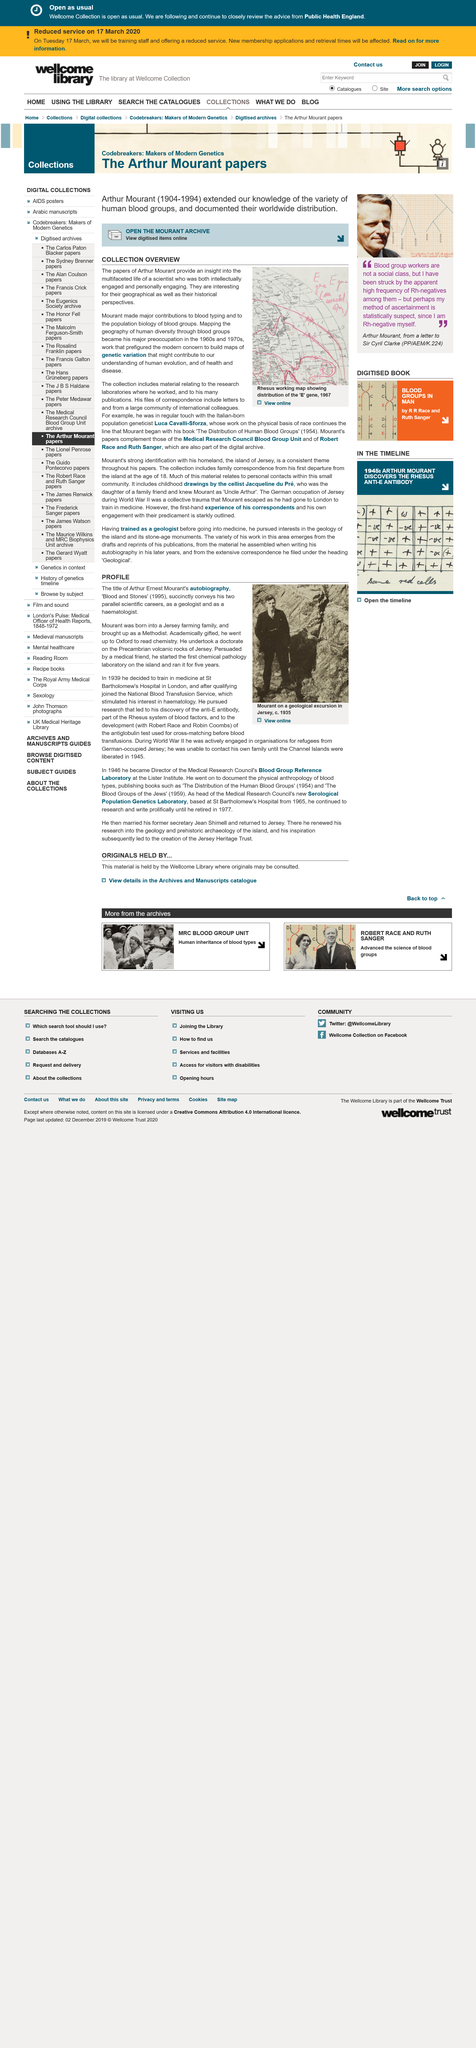List a handful of essential elements in this visual. Mourant started a chemist pathology laboratory in Jersey. Arthur Mourant made significant contributions to blood typing and population biology of blood groups. He did so. Mapping the geography of human diversity through blood groups became a major preoccupation of Mourant. Arthur Ernest Mourant's autobiography is titled "Blood and Stones. Arthur Ernest Mourant had two scientific careers, as both a geologist and a haematologist. 